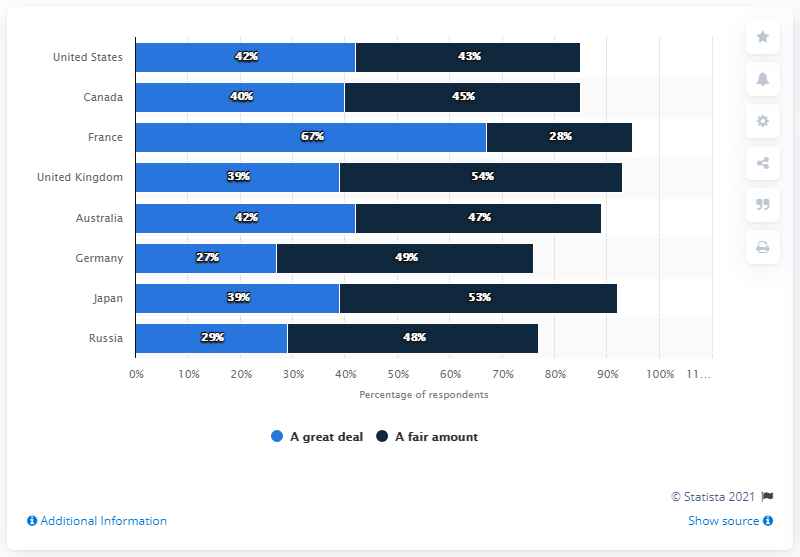Indicate a few pertinent items in this graphic. The average of a fair amount of Germany, Japan, and Russia is 50. France has the highest percentage in a great deal. 